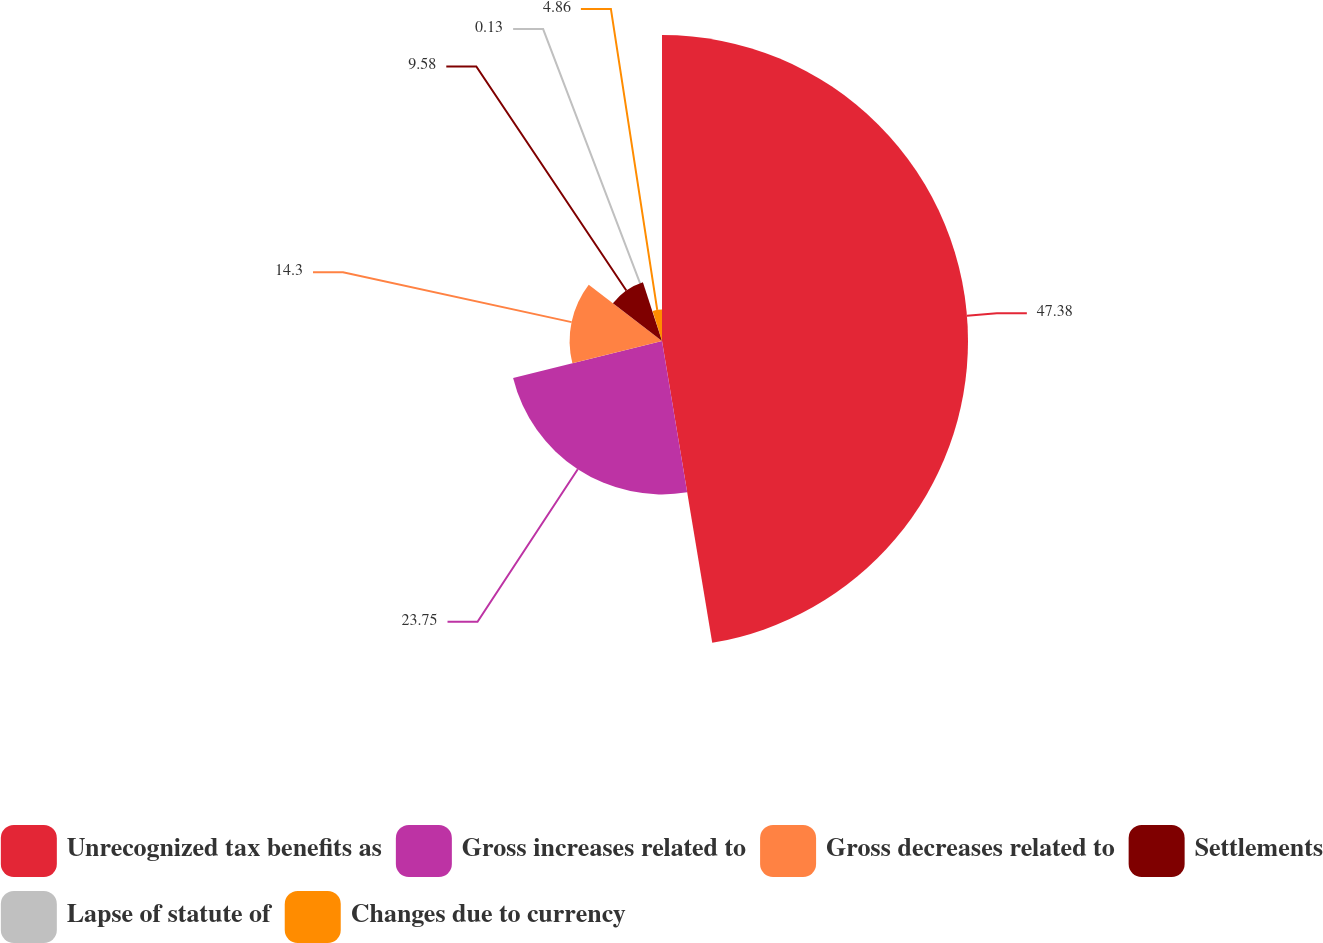Convert chart. <chart><loc_0><loc_0><loc_500><loc_500><pie_chart><fcel>Unrecognized tax benefits as<fcel>Gross increases related to<fcel>Gross decreases related to<fcel>Settlements<fcel>Lapse of statute of<fcel>Changes due to currency<nl><fcel>47.37%<fcel>23.75%<fcel>14.3%<fcel>9.58%<fcel>0.13%<fcel>4.86%<nl></chart> 